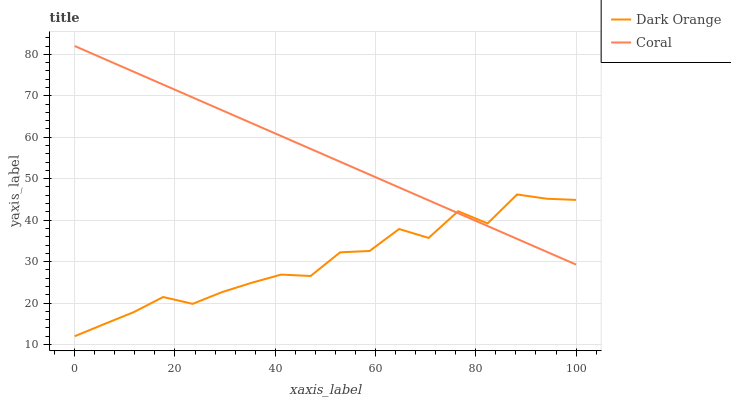Does Dark Orange have the minimum area under the curve?
Answer yes or no. Yes. Does Coral have the maximum area under the curve?
Answer yes or no. Yes. Does Coral have the minimum area under the curve?
Answer yes or no. No. Is Coral the smoothest?
Answer yes or no. Yes. Is Dark Orange the roughest?
Answer yes or no. Yes. Is Coral the roughest?
Answer yes or no. No. Does Dark Orange have the lowest value?
Answer yes or no. Yes. Does Coral have the lowest value?
Answer yes or no. No. Does Coral have the highest value?
Answer yes or no. Yes. Does Dark Orange intersect Coral?
Answer yes or no. Yes. Is Dark Orange less than Coral?
Answer yes or no. No. Is Dark Orange greater than Coral?
Answer yes or no. No. 